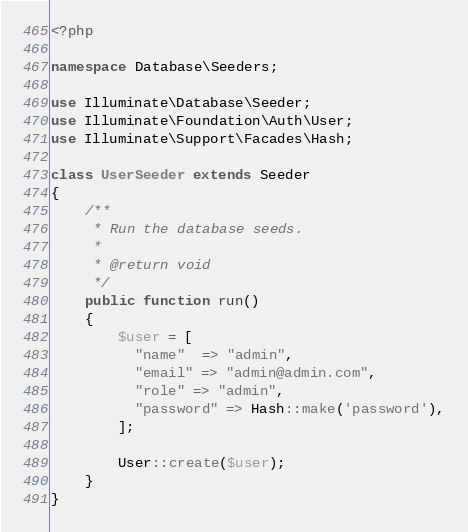Convert code to text. <code><loc_0><loc_0><loc_500><loc_500><_PHP_><?php

namespace Database\Seeders;

use Illuminate\Database\Seeder;
use Illuminate\Foundation\Auth\User;
use Illuminate\Support\Facades\Hash;

class UserSeeder extends Seeder
{
    /**
     * Run the database seeds.
     *
     * @return void
     */
    public function run()
    {
        $user = [
          "name"  => "admin",
          "email" => "admin@admin.com",
          "role" => "admin",
          "password" => Hash::make('password'),
        ];

        User::create($user);
    }
}
</code> 